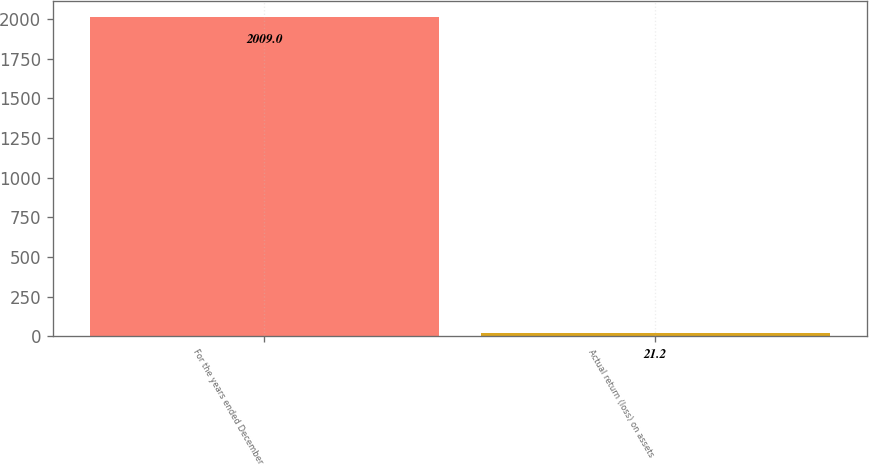Convert chart to OTSL. <chart><loc_0><loc_0><loc_500><loc_500><bar_chart><fcel>For the years ended December<fcel>Actual return (loss) on assets<nl><fcel>2009<fcel>21.2<nl></chart> 